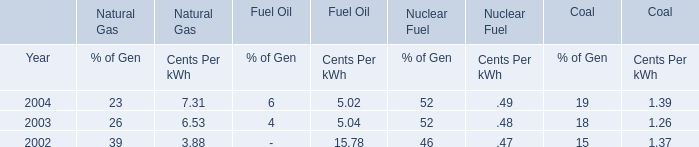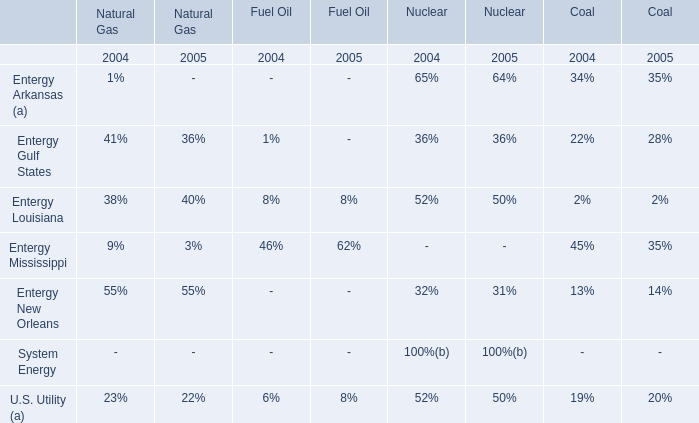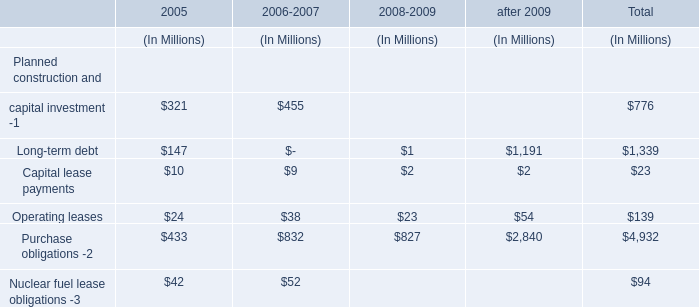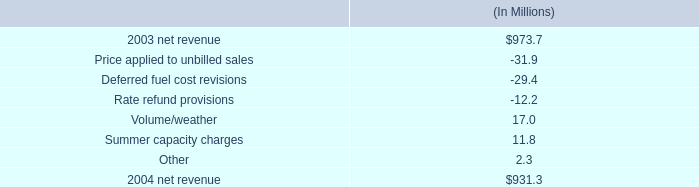what is the decrease in net income as a percentage of the the decrease in net revenue from 2003 to 2004? 
Computations: (18.7 / (973.7 - 931.3))
Answer: 0.44104. 